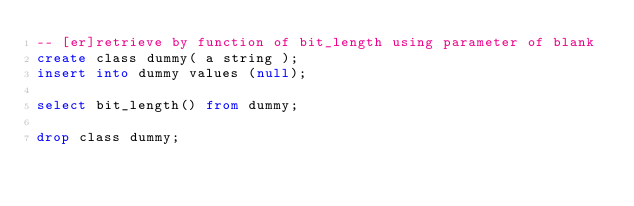Convert code to text. <code><loc_0><loc_0><loc_500><loc_500><_SQL_>-- [er]retrieve by function of bit_length using parameter of blank
create class dummy( a string );
insert into dummy values (null);
 
select bit_length() from dummy;
 
drop class dummy;

</code> 